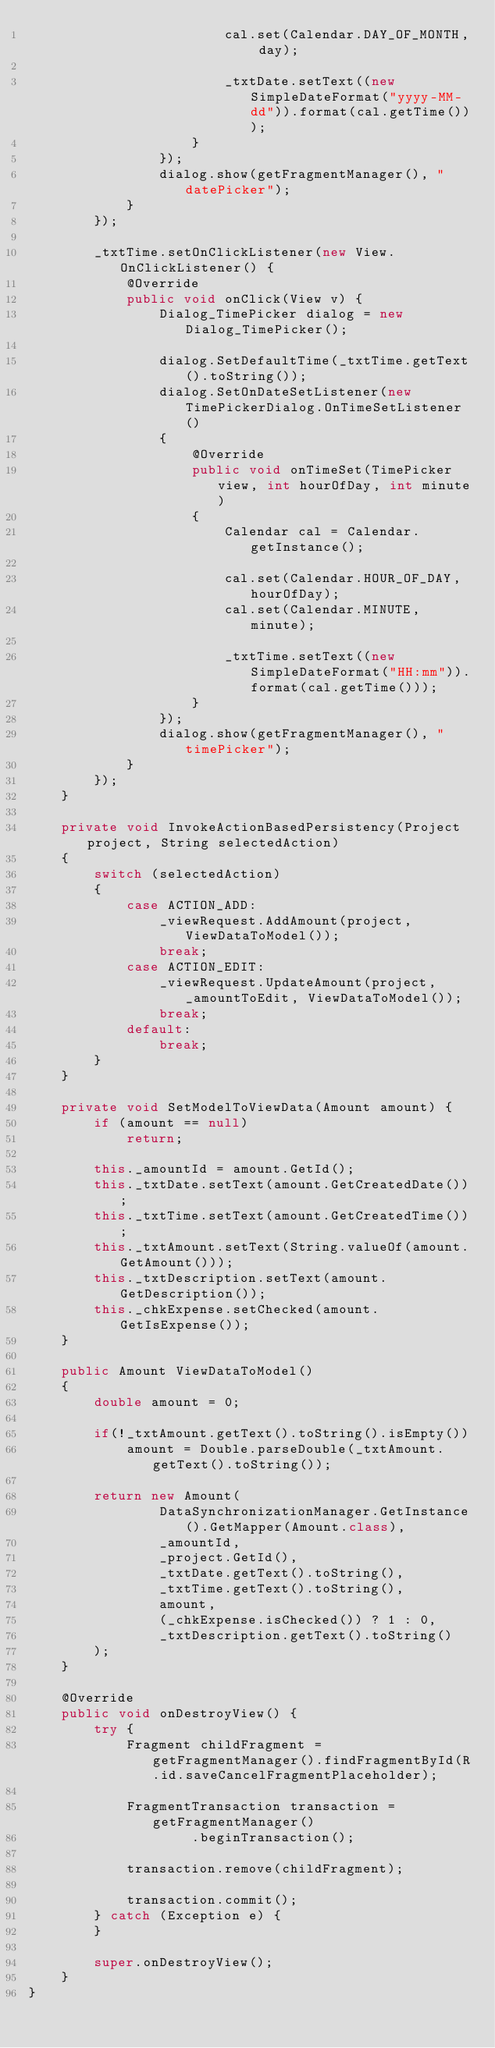Convert code to text. <code><loc_0><loc_0><loc_500><loc_500><_Java_>                        cal.set(Calendar.DAY_OF_MONTH, day);

                        _txtDate.setText((new SimpleDateFormat("yyyy-MM-dd")).format(cal.getTime()));
                    }
                });
                dialog.show(getFragmentManager(), "datePicker");
            }
        });

        _txtTime.setOnClickListener(new View.OnClickListener() {
            @Override
            public void onClick(View v) {
                Dialog_TimePicker dialog = new Dialog_TimePicker();

                dialog.SetDefaultTime(_txtTime.getText().toString());
                dialog.SetOnDateSetListener(new TimePickerDialog.OnTimeSetListener()
                {
                    @Override
                    public void onTimeSet(TimePicker view, int hourOfDay, int minute)
                    {
                        Calendar cal = Calendar.getInstance();

                        cal.set(Calendar.HOUR_OF_DAY, hourOfDay);
                        cal.set(Calendar.MINUTE, minute);

                        _txtTime.setText((new SimpleDateFormat("HH:mm")).format(cal.getTime()));
                    }
                });
                dialog.show(getFragmentManager(), "timePicker");
            }
        });
    }

    private void InvokeActionBasedPersistency(Project project, String selectedAction)
    {
        switch (selectedAction)
        {
            case ACTION_ADD:
                _viewRequest.AddAmount(project, ViewDataToModel());
                break;
            case ACTION_EDIT:
                _viewRequest.UpdateAmount(project, _amountToEdit, ViewDataToModel());
                break;
            default:
                break;
        }
    }

    private void SetModelToViewData(Amount amount) {
        if (amount == null)
            return;

        this._amountId = amount.GetId();
        this._txtDate.setText(amount.GetCreatedDate());
        this._txtTime.setText(amount.GetCreatedTime());
        this._txtAmount.setText(String.valueOf(amount.GetAmount()));
        this._txtDescription.setText(amount.GetDescription());
        this._chkExpense.setChecked(amount.GetIsExpense());
    }

    public Amount ViewDataToModel()
    {
        double amount = 0;

        if(!_txtAmount.getText().toString().isEmpty())
            amount = Double.parseDouble(_txtAmount.getText().toString());

        return new Amount(
                DataSynchronizationManager.GetInstance().GetMapper(Amount.class),
                _amountId,
                _project.GetId(),
                _txtDate.getText().toString(),
                _txtTime.getText().toString(),
                amount,
                (_chkExpense.isChecked()) ? 1 : 0,
                _txtDescription.getText().toString()
        );
    }

    @Override
    public void onDestroyView() {
        try {
            Fragment childFragment = getFragmentManager().findFragmentById(R.id.saveCancelFragmentPlaceholder);

            FragmentTransaction transaction = getFragmentManager()
                    .beginTransaction();

            transaction.remove(childFragment);

            transaction.commit();
        } catch (Exception e) {
        }

        super.onDestroyView();
    }
}
</code> 